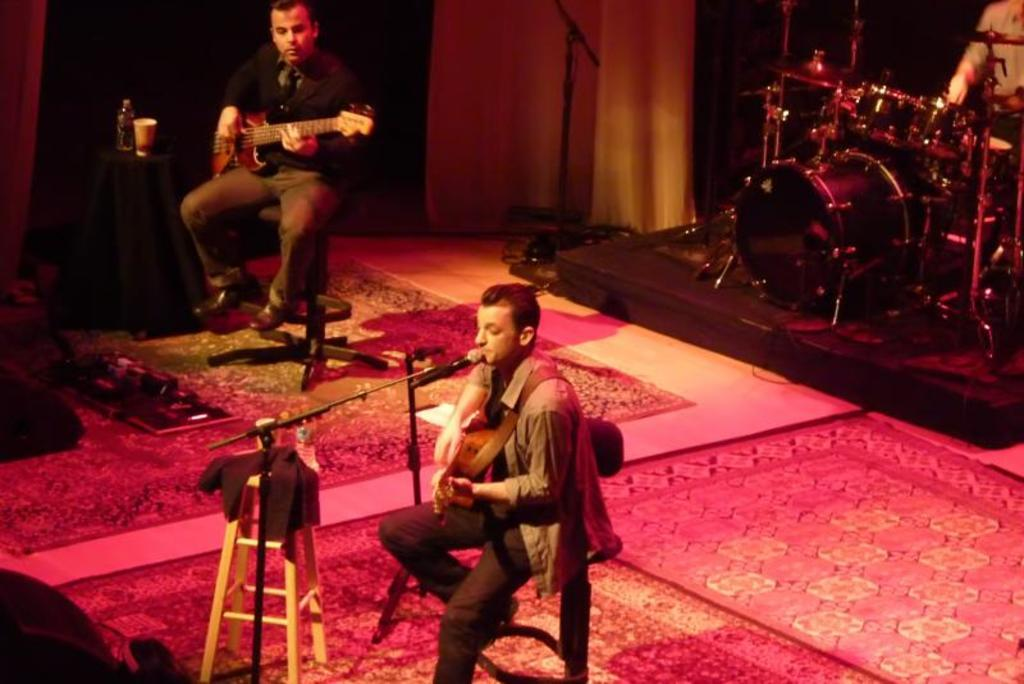What are the people in the image doing? The people in the image are playing musical instruments. Where are the people sitting while playing their instruments? The people are sitting on a chair. What type of stone is being used to play the musical instruments in the image? There is no stone present in the image, and the musical instruments are being played by people, not stones. 